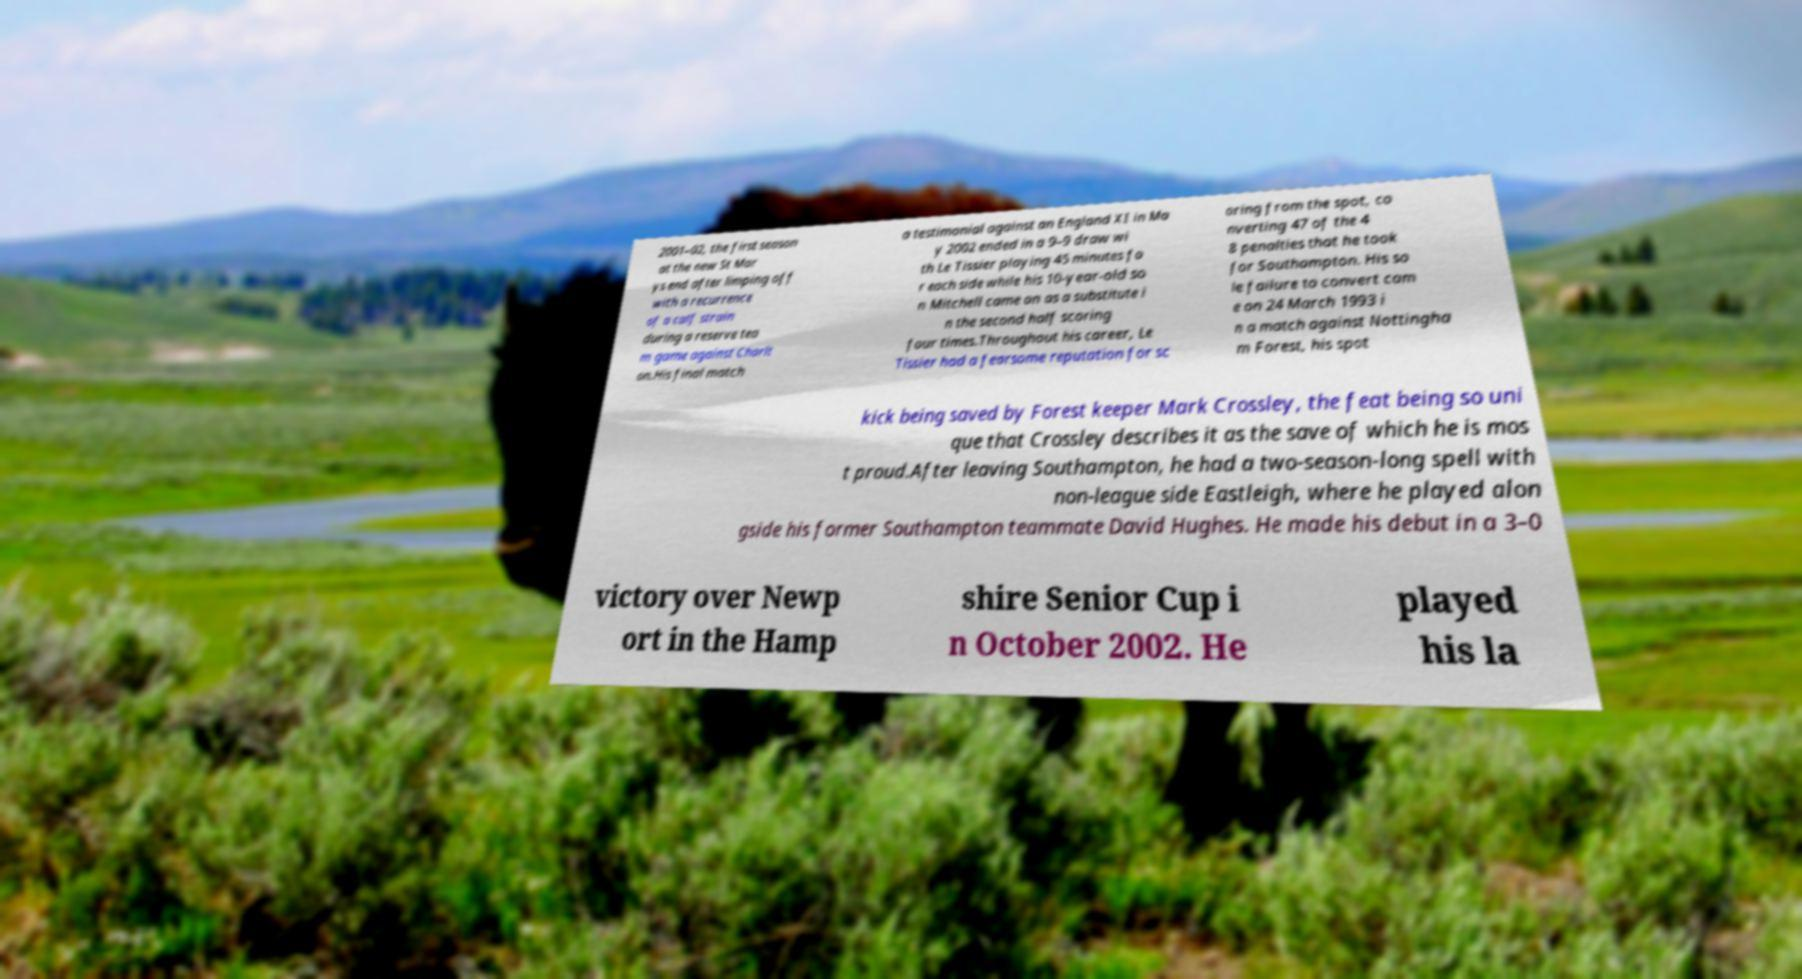Please identify and transcribe the text found in this image. 2001–02, the first season at the new St Mar ys end after limping off with a recurrence of a calf strain during a reserve tea m game against Charlt on.His final match a testimonial against an England XI in Ma y 2002 ended in a 9–9 draw wi th Le Tissier playing 45 minutes fo r each side while his 10-year-old so n Mitchell came on as a substitute i n the second half scoring four times.Throughout his career, Le Tissier had a fearsome reputation for sc oring from the spot, co nverting 47 of the 4 8 penalties that he took for Southampton. His so le failure to convert cam e on 24 March 1993 i n a match against Nottingha m Forest, his spot kick being saved by Forest keeper Mark Crossley, the feat being so uni que that Crossley describes it as the save of which he is mos t proud.After leaving Southampton, he had a two-season-long spell with non-league side Eastleigh, where he played alon gside his former Southampton teammate David Hughes. He made his debut in a 3–0 victory over Newp ort in the Hamp shire Senior Cup i n October 2002. He played his la 